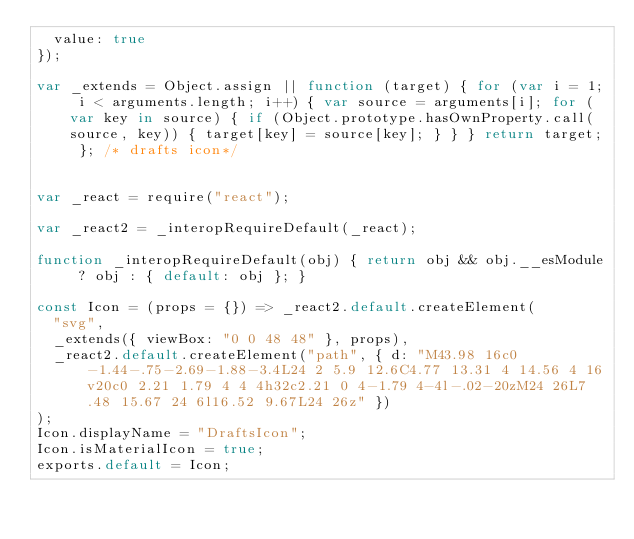Convert code to text. <code><loc_0><loc_0><loc_500><loc_500><_JavaScript_>  value: true
});

var _extends = Object.assign || function (target) { for (var i = 1; i < arguments.length; i++) { var source = arguments[i]; for (var key in source) { if (Object.prototype.hasOwnProperty.call(source, key)) { target[key] = source[key]; } } } return target; }; /* drafts icon*/


var _react = require("react");

var _react2 = _interopRequireDefault(_react);

function _interopRequireDefault(obj) { return obj && obj.__esModule ? obj : { default: obj }; }

const Icon = (props = {}) => _react2.default.createElement(
  "svg",
  _extends({ viewBox: "0 0 48 48" }, props),
  _react2.default.createElement("path", { d: "M43.98 16c0-1.44-.75-2.69-1.88-3.4L24 2 5.9 12.6C4.77 13.31 4 14.56 4 16v20c0 2.21 1.79 4 4 4h32c2.21 0 4-1.79 4-4l-.02-20zM24 26L7.48 15.67 24 6l16.52 9.67L24 26z" })
);
Icon.displayName = "DraftsIcon";
Icon.isMaterialIcon = true;
exports.default = Icon;</code> 